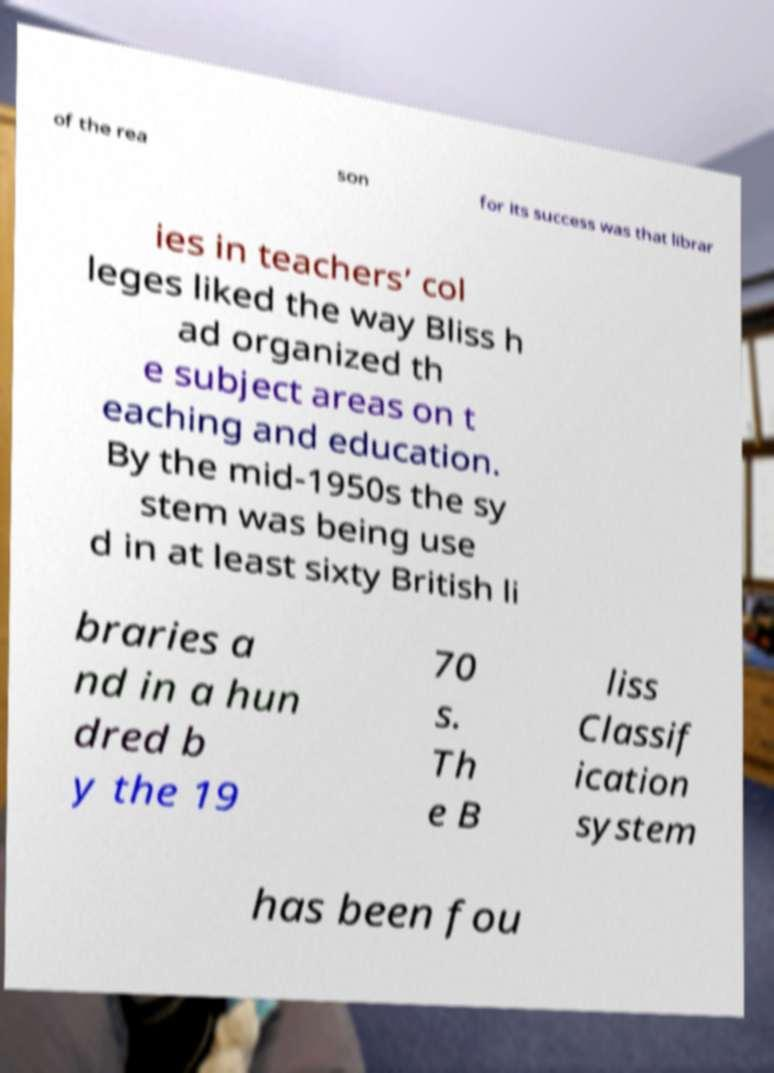Could you extract and type out the text from this image? of the rea son for its success was that librar ies in teachers’ col leges liked the way Bliss h ad organized th e subject areas on t eaching and education. By the mid-1950s the sy stem was being use d in at least sixty British li braries a nd in a hun dred b y the 19 70 s. Th e B liss Classif ication system has been fou 